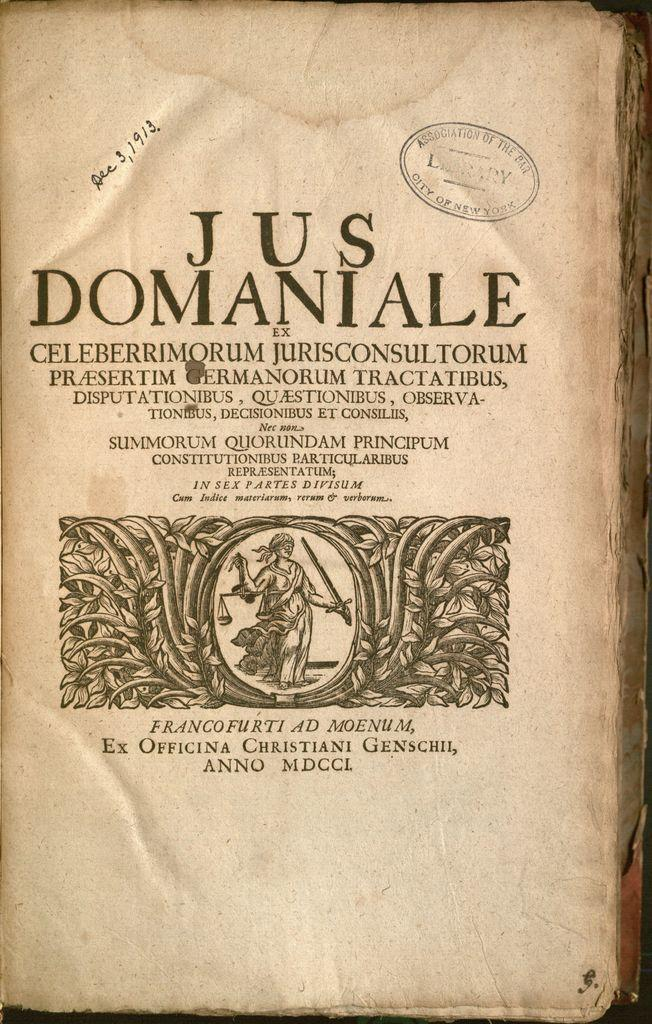<image>
Describe the image concisely. A page in this book from Association of the Bar, City of New York says Jus Domaniale. 